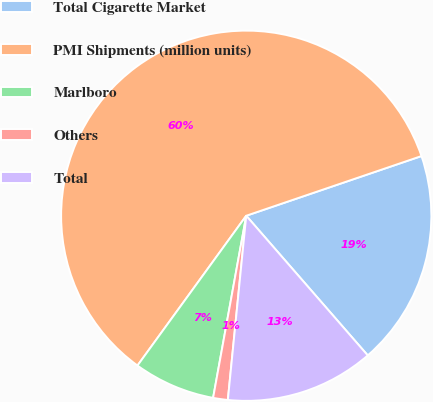Convert chart to OTSL. <chart><loc_0><loc_0><loc_500><loc_500><pie_chart><fcel>Total Cigarette Market<fcel>PMI Shipments (million units)<fcel>Marlboro<fcel>Others<fcel>Total<nl><fcel>18.83%<fcel>59.78%<fcel>7.13%<fcel>1.28%<fcel>12.98%<nl></chart> 